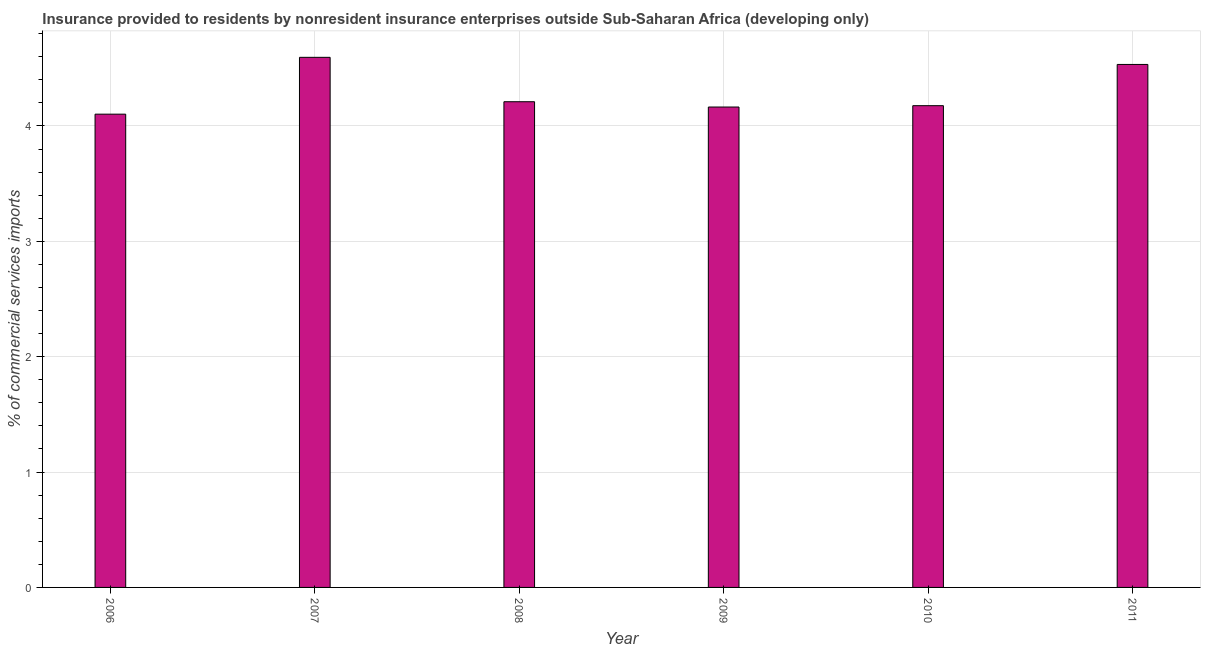What is the title of the graph?
Give a very brief answer. Insurance provided to residents by nonresident insurance enterprises outside Sub-Saharan Africa (developing only). What is the label or title of the Y-axis?
Offer a very short reply. % of commercial services imports. What is the insurance provided by non-residents in 2008?
Your answer should be compact. 4.21. Across all years, what is the maximum insurance provided by non-residents?
Ensure brevity in your answer.  4.59. Across all years, what is the minimum insurance provided by non-residents?
Your response must be concise. 4.1. In which year was the insurance provided by non-residents maximum?
Your answer should be compact. 2007. What is the sum of the insurance provided by non-residents?
Ensure brevity in your answer.  25.78. What is the difference between the insurance provided by non-residents in 2008 and 2009?
Provide a succinct answer. 0.05. What is the average insurance provided by non-residents per year?
Provide a succinct answer. 4.3. What is the median insurance provided by non-residents?
Provide a short and direct response. 4.19. Do a majority of the years between 2008 and 2011 (inclusive) have insurance provided by non-residents greater than 1 %?
Your answer should be compact. Yes. What is the ratio of the insurance provided by non-residents in 2009 to that in 2011?
Your answer should be compact. 0.92. Is the insurance provided by non-residents in 2006 less than that in 2011?
Keep it short and to the point. Yes. Is the difference between the insurance provided by non-residents in 2006 and 2009 greater than the difference between any two years?
Give a very brief answer. No. What is the difference between the highest and the second highest insurance provided by non-residents?
Provide a short and direct response. 0.06. What is the difference between the highest and the lowest insurance provided by non-residents?
Provide a succinct answer. 0.49. In how many years, is the insurance provided by non-residents greater than the average insurance provided by non-residents taken over all years?
Provide a short and direct response. 2. How many bars are there?
Make the answer very short. 6. Are all the bars in the graph horizontal?
Your answer should be very brief. No. Are the values on the major ticks of Y-axis written in scientific E-notation?
Offer a terse response. No. What is the % of commercial services imports in 2006?
Your answer should be compact. 4.1. What is the % of commercial services imports in 2007?
Provide a succinct answer. 4.59. What is the % of commercial services imports in 2008?
Ensure brevity in your answer.  4.21. What is the % of commercial services imports of 2009?
Ensure brevity in your answer.  4.16. What is the % of commercial services imports of 2010?
Give a very brief answer. 4.18. What is the % of commercial services imports of 2011?
Provide a short and direct response. 4.53. What is the difference between the % of commercial services imports in 2006 and 2007?
Your response must be concise. -0.49. What is the difference between the % of commercial services imports in 2006 and 2008?
Keep it short and to the point. -0.11. What is the difference between the % of commercial services imports in 2006 and 2009?
Offer a terse response. -0.06. What is the difference between the % of commercial services imports in 2006 and 2010?
Make the answer very short. -0.07. What is the difference between the % of commercial services imports in 2006 and 2011?
Offer a very short reply. -0.43. What is the difference between the % of commercial services imports in 2007 and 2008?
Give a very brief answer. 0.38. What is the difference between the % of commercial services imports in 2007 and 2009?
Ensure brevity in your answer.  0.43. What is the difference between the % of commercial services imports in 2007 and 2010?
Your answer should be compact. 0.42. What is the difference between the % of commercial services imports in 2007 and 2011?
Provide a short and direct response. 0.06. What is the difference between the % of commercial services imports in 2008 and 2009?
Make the answer very short. 0.05. What is the difference between the % of commercial services imports in 2008 and 2010?
Provide a succinct answer. 0.03. What is the difference between the % of commercial services imports in 2008 and 2011?
Keep it short and to the point. -0.32. What is the difference between the % of commercial services imports in 2009 and 2010?
Your response must be concise. -0.01. What is the difference between the % of commercial services imports in 2009 and 2011?
Your answer should be very brief. -0.37. What is the difference between the % of commercial services imports in 2010 and 2011?
Your answer should be very brief. -0.36. What is the ratio of the % of commercial services imports in 2006 to that in 2007?
Keep it short and to the point. 0.89. What is the ratio of the % of commercial services imports in 2006 to that in 2010?
Offer a very short reply. 0.98. What is the ratio of the % of commercial services imports in 2006 to that in 2011?
Your answer should be compact. 0.91. What is the ratio of the % of commercial services imports in 2007 to that in 2008?
Your answer should be compact. 1.09. What is the ratio of the % of commercial services imports in 2007 to that in 2009?
Ensure brevity in your answer.  1.1. What is the ratio of the % of commercial services imports in 2007 to that in 2010?
Offer a terse response. 1.1. What is the ratio of the % of commercial services imports in 2008 to that in 2009?
Keep it short and to the point. 1.01. What is the ratio of the % of commercial services imports in 2008 to that in 2010?
Offer a very short reply. 1.01. What is the ratio of the % of commercial services imports in 2008 to that in 2011?
Your answer should be compact. 0.93. What is the ratio of the % of commercial services imports in 2009 to that in 2011?
Keep it short and to the point. 0.92. What is the ratio of the % of commercial services imports in 2010 to that in 2011?
Ensure brevity in your answer.  0.92. 